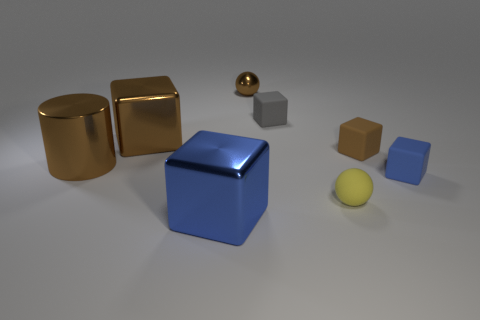How many big objects are behind the metal cylinder?
Make the answer very short. 1. Is the number of metal spheres to the right of the small blue matte thing less than the number of small brown things left of the big blue shiny thing?
Your answer should be compact. No. The large brown thing that is on the right side of the big brown thing that is in front of the tiny brown thing right of the tiny metallic thing is what shape?
Keep it short and to the point. Cube. What shape is the large thing that is behind the yellow sphere and in front of the tiny brown rubber block?
Provide a succinct answer. Cylinder. Are there any gray things that have the same material as the yellow sphere?
Offer a terse response. Yes. The cylinder that is the same color as the small metal ball is what size?
Offer a very short reply. Large. What is the color of the sphere that is on the right side of the tiny metal sphere?
Give a very brief answer. Yellow. Do the big blue object and the tiny brown object that is in front of the shiny sphere have the same shape?
Provide a short and direct response. Yes. Are there any large shiny things of the same color as the metallic sphere?
Your response must be concise. Yes. What is the size of the brown ball that is made of the same material as the large blue block?
Provide a succinct answer. Small. 